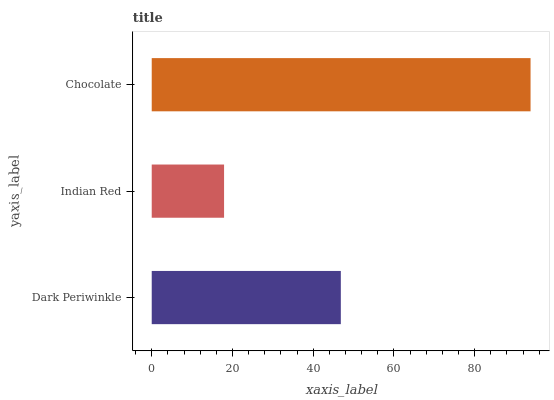Is Indian Red the minimum?
Answer yes or no. Yes. Is Chocolate the maximum?
Answer yes or no. Yes. Is Chocolate the minimum?
Answer yes or no. No. Is Indian Red the maximum?
Answer yes or no. No. Is Chocolate greater than Indian Red?
Answer yes or no. Yes. Is Indian Red less than Chocolate?
Answer yes or no. Yes. Is Indian Red greater than Chocolate?
Answer yes or no. No. Is Chocolate less than Indian Red?
Answer yes or no. No. Is Dark Periwinkle the high median?
Answer yes or no. Yes. Is Dark Periwinkle the low median?
Answer yes or no. Yes. Is Indian Red the high median?
Answer yes or no. No. Is Indian Red the low median?
Answer yes or no. No. 